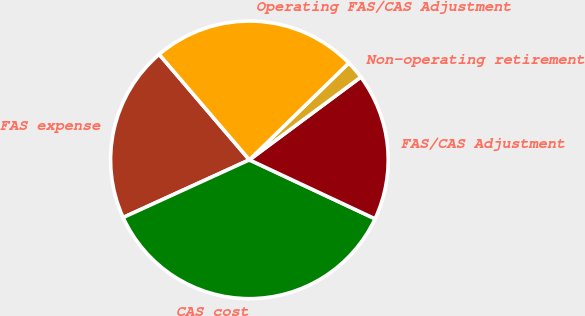Convert chart to OTSL. <chart><loc_0><loc_0><loc_500><loc_500><pie_chart><fcel>FAS expense<fcel>CAS cost<fcel>FAS/CAS Adjustment<fcel>Non-operating retirement<fcel>Operating FAS/CAS Adjustment<nl><fcel>20.56%<fcel>36.2%<fcel>17.15%<fcel>2.13%<fcel>23.96%<nl></chart> 